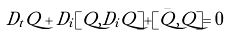Convert formula to latex. <formula><loc_0><loc_0><loc_500><loc_500>D _ { t } Q + D _ { i } [ Q , D _ { i } Q ] + [ \bar { Q } , Q ] = 0</formula> 